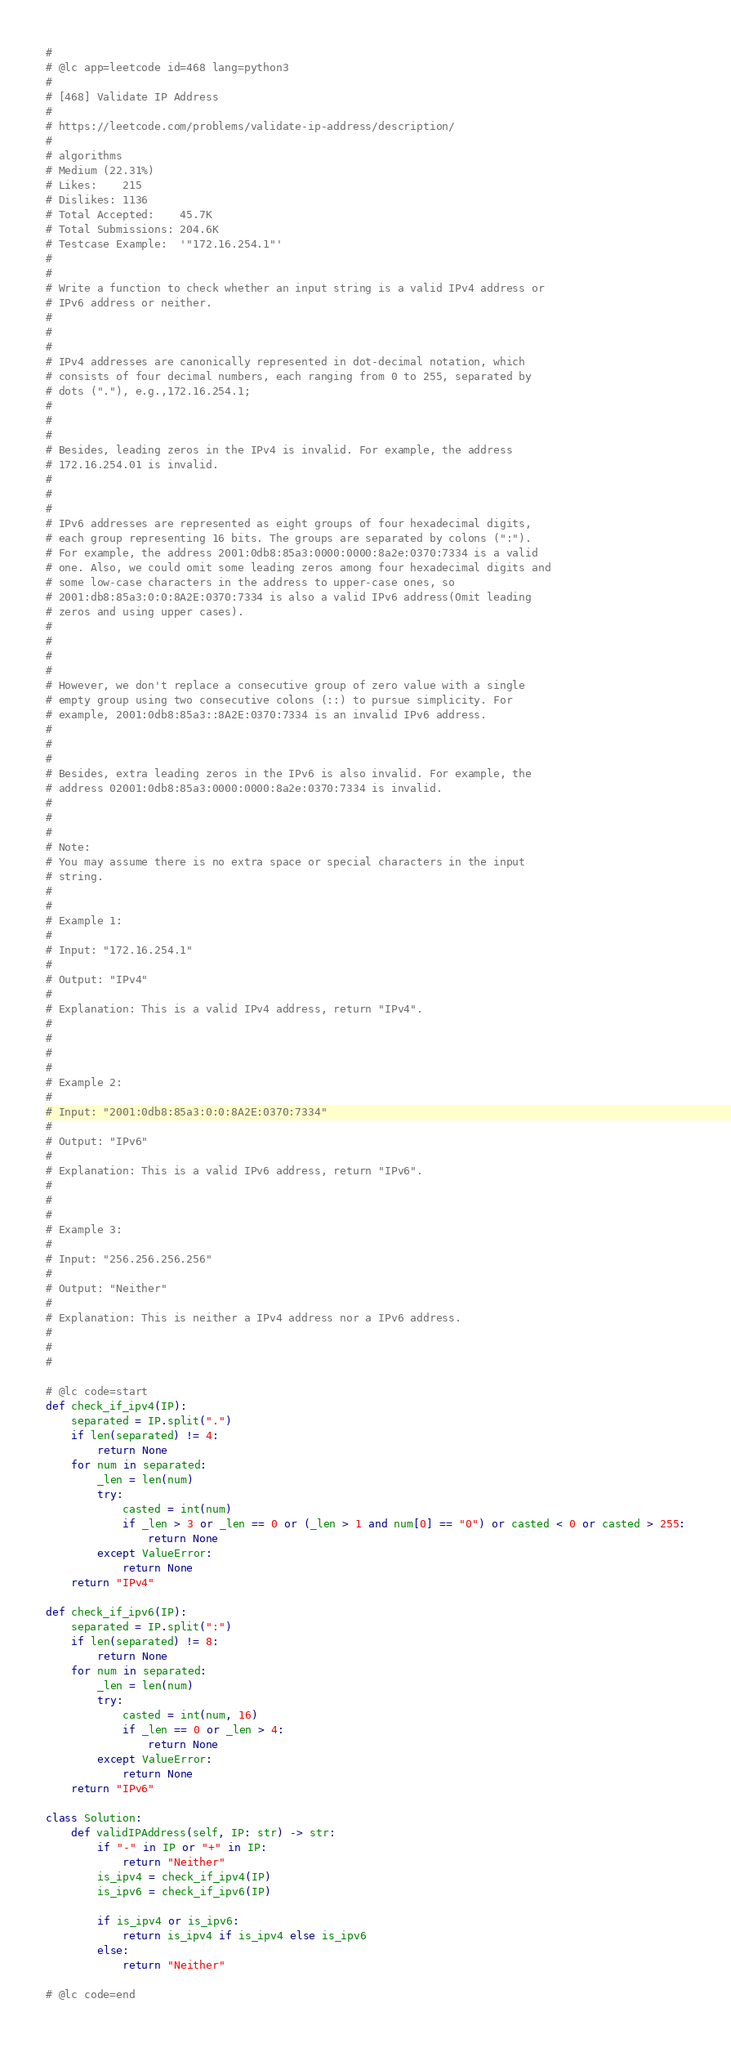<code> <loc_0><loc_0><loc_500><loc_500><_Python_>#
# @lc app=leetcode id=468 lang=python3
#
# [468] Validate IP Address
#
# https://leetcode.com/problems/validate-ip-address/description/
#
# algorithms
# Medium (22.31%)
# Likes:    215
# Dislikes: 1136
# Total Accepted:    45.7K
# Total Submissions: 204.6K
# Testcase Example:  '"172.16.254.1"'
#
# 
# Write a function to check whether an input string is a valid IPv4 address or
# IPv6 address or neither.
# 
# 
# 
# IPv4 addresses are canonically represented in dot-decimal notation, which
# consists of four decimal numbers, each ranging from 0 to 255, separated by
# dots ("."), e.g.,172.16.254.1;
# 
# 
# 
# Besides, leading zeros in the IPv4 is invalid. For example, the address
# 172.16.254.01 is invalid.
# 
# 
# 
# IPv6 addresses are represented as eight groups of four hexadecimal digits,
# each group representing 16 bits. The groups are separated by colons (":").
# For example, the address 2001:0db8:85a3:0000:0000:8a2e:0370:7334 is a valid
# one. Also, we could omit some leading zeros among four hexadecimal digits and
# some low-case characters in the address to upper-case ones, so
# 2001:db8:85a3:0:0:8A2E:0370:7334 is also a valid IPv6 address(Omit leading
# zeros and using upper cases).
# 
# 
# 
# 
# However, we don't replace a consecutive group of zero value with a single
# empty group using two consecutive colons (::) to pursue simplicity. For
# example, 2001:0db8:85a3::8A2E:0370:7334 is an invalid IPv6 address.
# 
# 
# 
# Besides, extra leading zeros in the IPv6 is also invalid. For example, the
# address 02001:0db8:85a3:0000:0000:8a2e:0370:7334 is invalid.
# 
# 
# 
# Note:
# You may assume there is no extra space or special characters in the input
# string.
# 
# 
# Example 1:
# 
# Input: "172.16.254.1"
# 
# Output: "IPv4"
# 
# Explanation: This is a valid IPv4 address, return "IPv4".
# 
# 
# 
# 
# Example 2:
# 
# Input: "2001:0db8:85a3:0:0:8A2E:0370:7334"
# 
# Output: "IPv6"
# 
# Explanation: This is a valid IPv6 address, return "IPv6".
# 
# 
# 
# Example 3:
# 
# Input: "256.256.256.256"
# 
# Output: "Neither"
# 
# Explanation: This is neither a IPv4 address nor a IPv6 address.
# 
# 
#

# @lc code=start
def check_if_ipv4(IP):
    separated = IP.split(".")
    if len(separated) != 4:
        return None
    for num in separated:
        _len = len(num)
        try:
            casted = int(num)
            if _len > 3 or _len == 0 or (_len > 1 and num[0] == "0") or casted < 0 or casted > 255:
                return None
        except ValueError:
            return None
    return "IPv4"
    
def check_if_ipv6(IP):
    separated = IP.split(":")
    if len(separated) != 8:
        return None
    for num in separated:
        _len = len(num)
        try:
            casted = int(num, 16)
            if _len == 0 or _len > 4:
                return None
        except ValueError:
            return None
    return "IPv6"

class Solution:
    def validIPAddress(self, IP: str) -> str:
        if "-" in IP or "+" in IP:
            return "Neither"
        is_ipv4 = check_if_ipv4(IP)
        is_ipv6 = check_if_ipv6(IP)
        
        if is_ipv4 or is_ipv6:
            return is_ipv4 if is_ipv4 else is_ipv6
        else:
            return "Neither"

# @lc code=end
</code> 